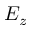<formula> <loc_0><loc_0><loc_500><loc_500>E _ { z }</formula> 